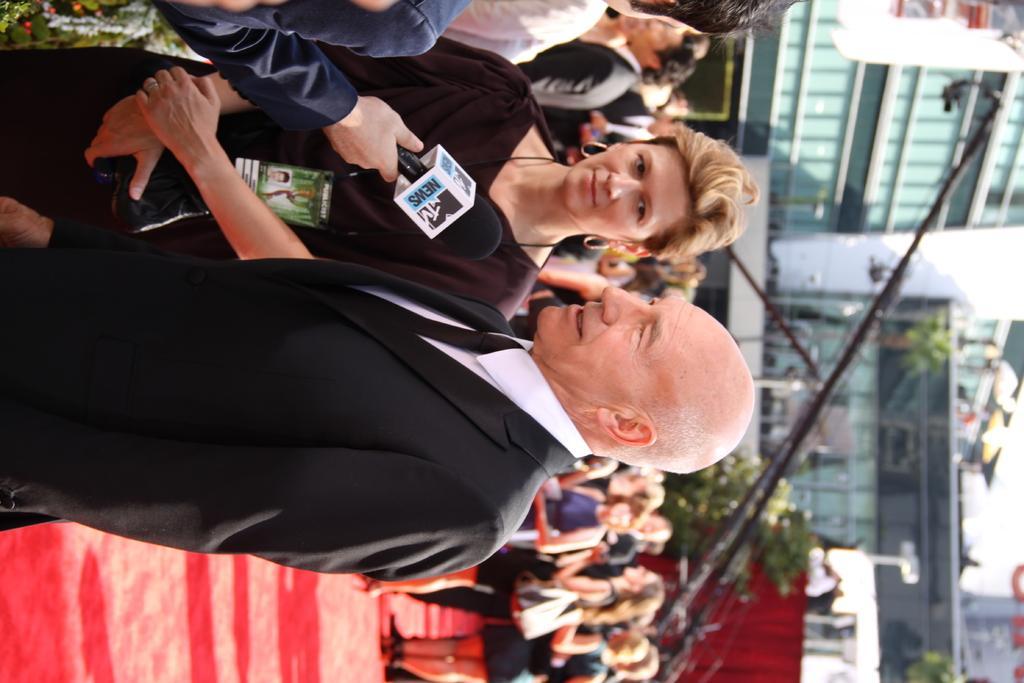Describe this image in one or two sentences. In this image, I can see groups of people standing. At the top of the image, I can see a person's hand holding a mike. On the right side of the image, there are trees, a building and a camera crane. 